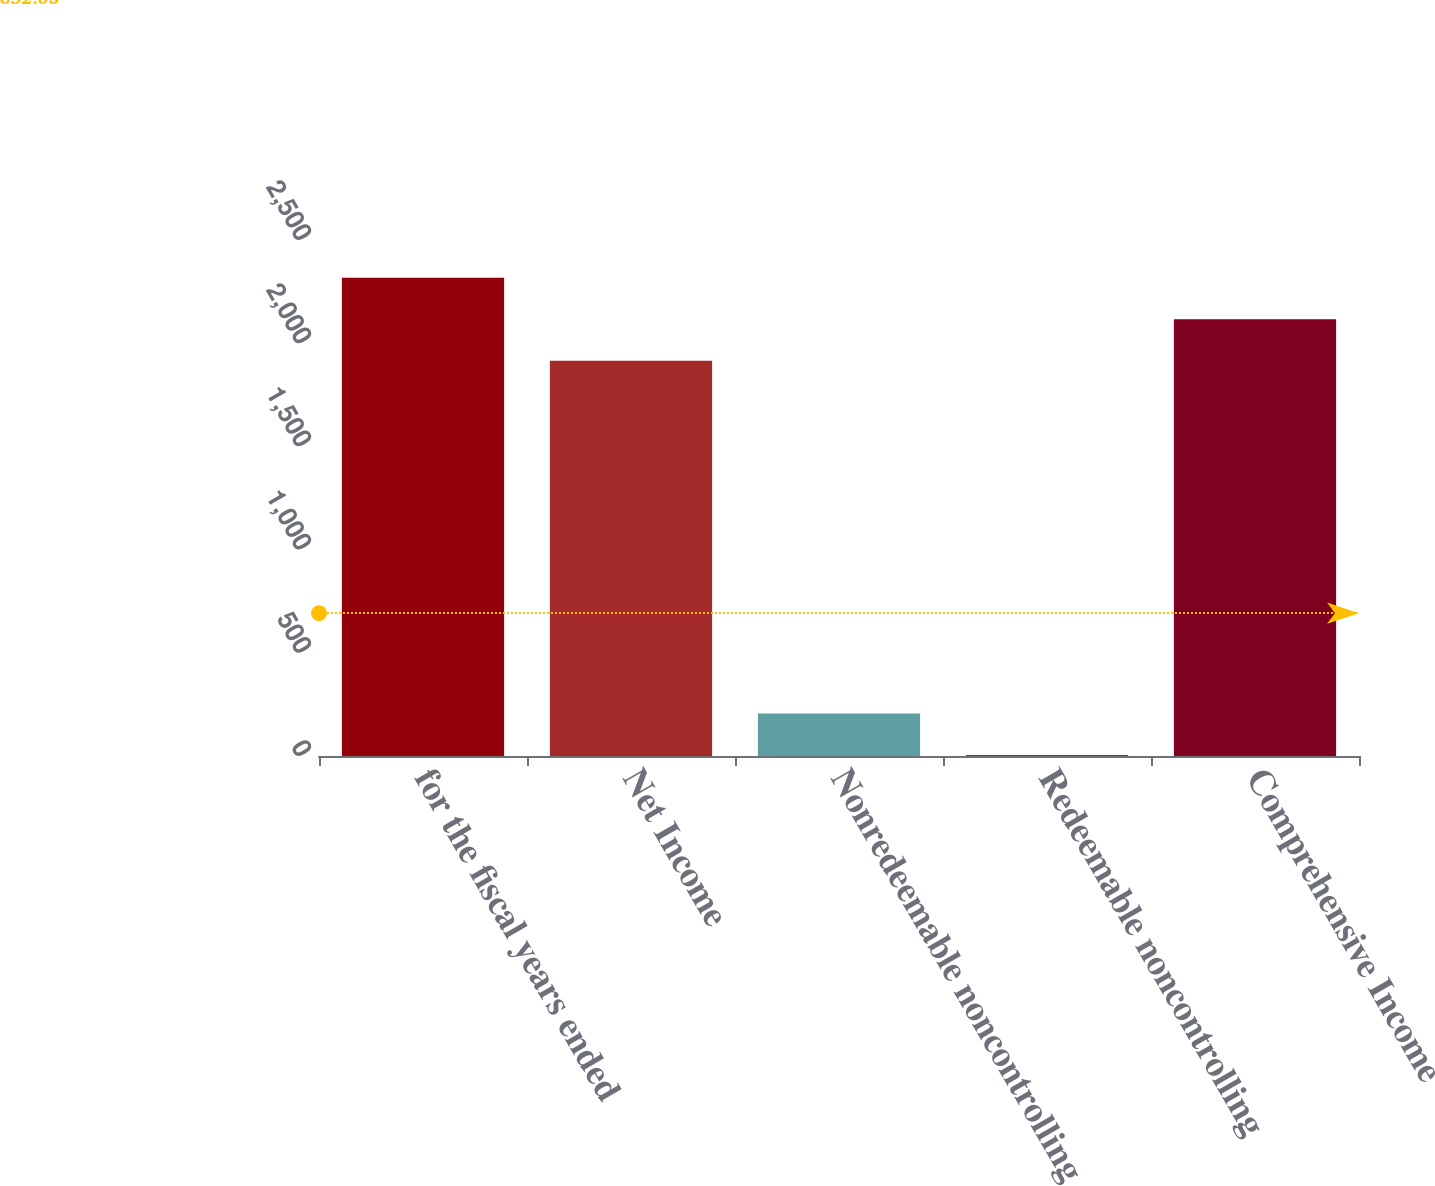Convert chart. <chart><loc_0><loc_0><loc_500><loc_500><bar_chart><fcel>for the fiscal years ended<fcel>Net Income<fcel>Nonredeemable noncontrolling<fcel>Redeemable noncontrolling<fcel>Comprehensive Income<nl><fcel>2316.9<fcel>1915.5<fcel>205.7<fcel>5<fcel>2116.2<nl></chart> 